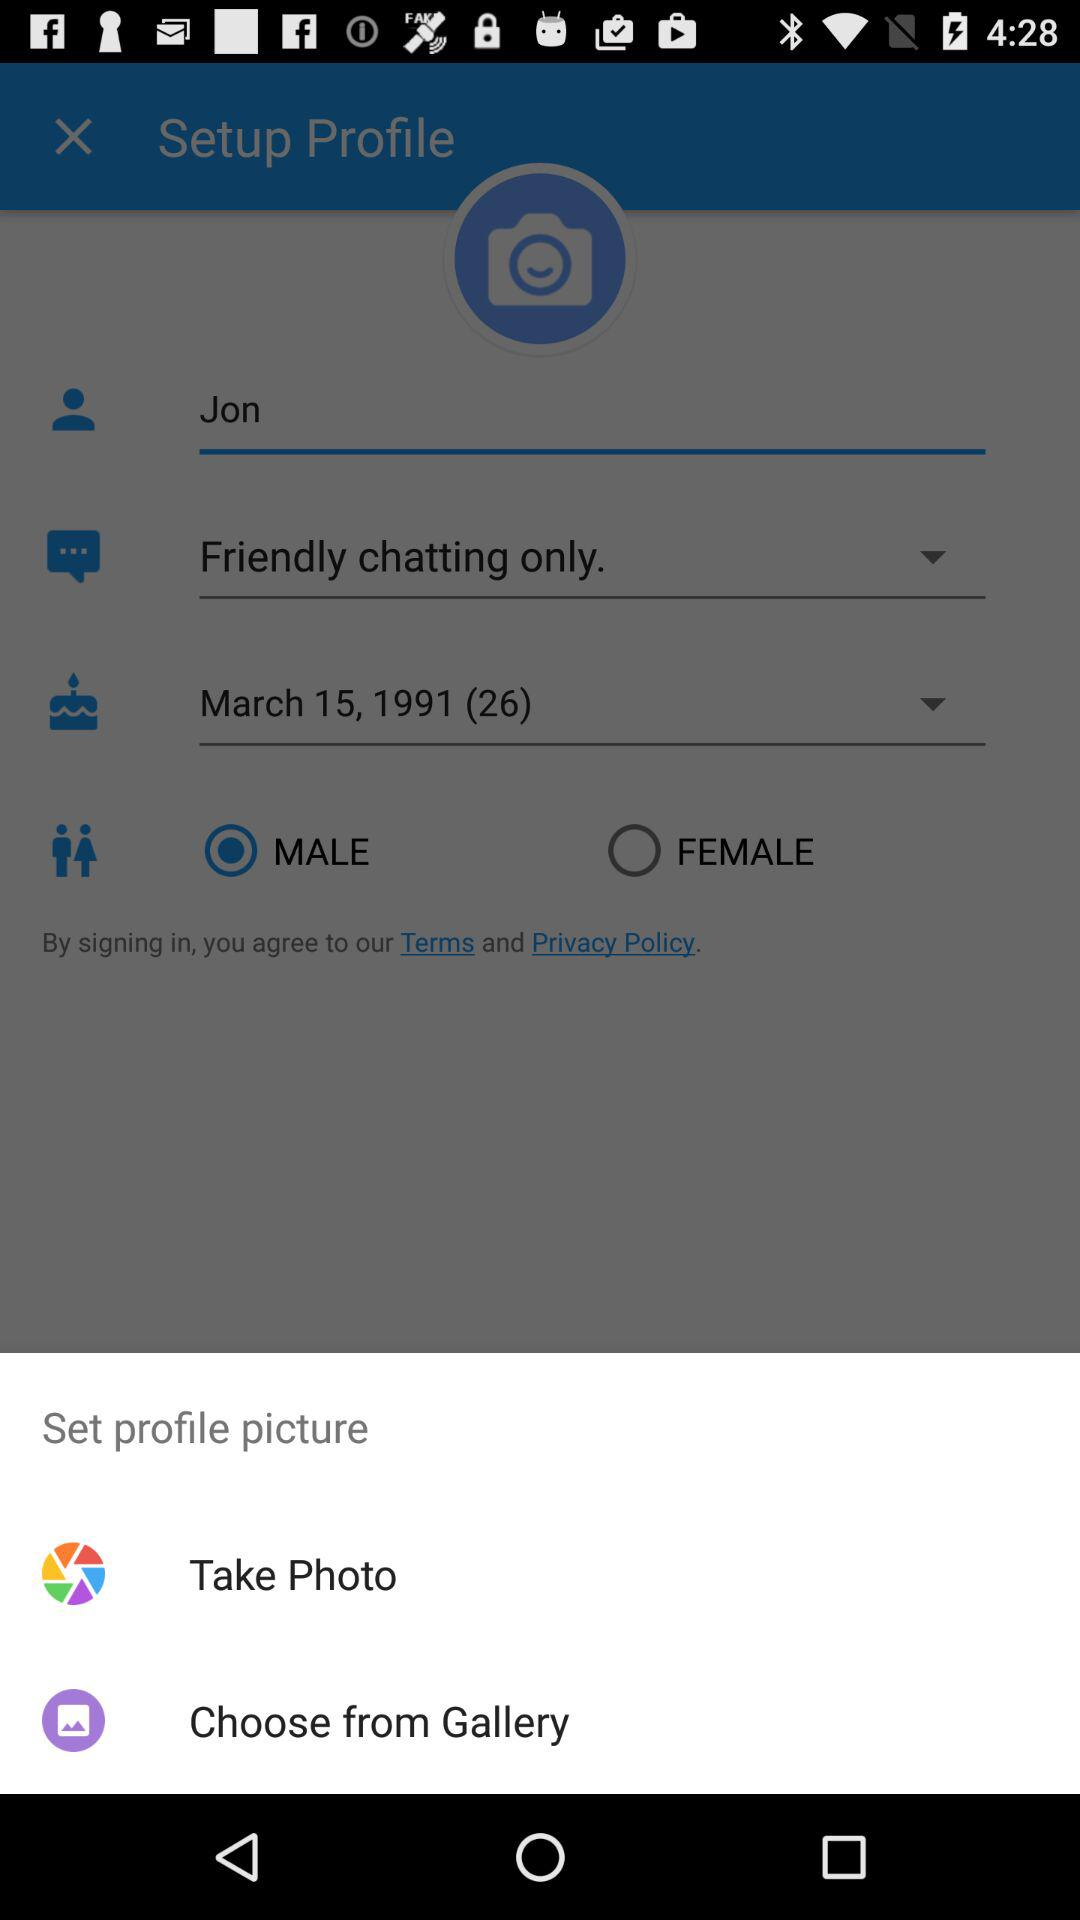What is the selected gender? The selected gender is male. 